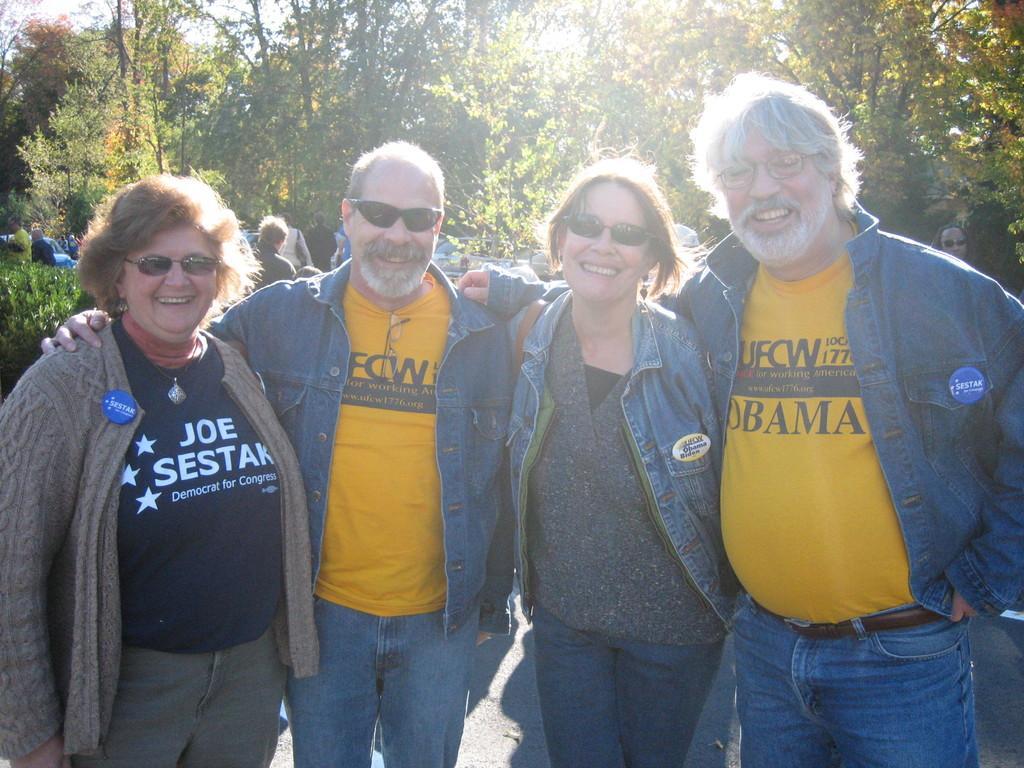Describe this image in one or two sentences. In the foreground of this picture, there are four persons standing and posing to the camera. In the background, there are few persons, trees, and the sky. 